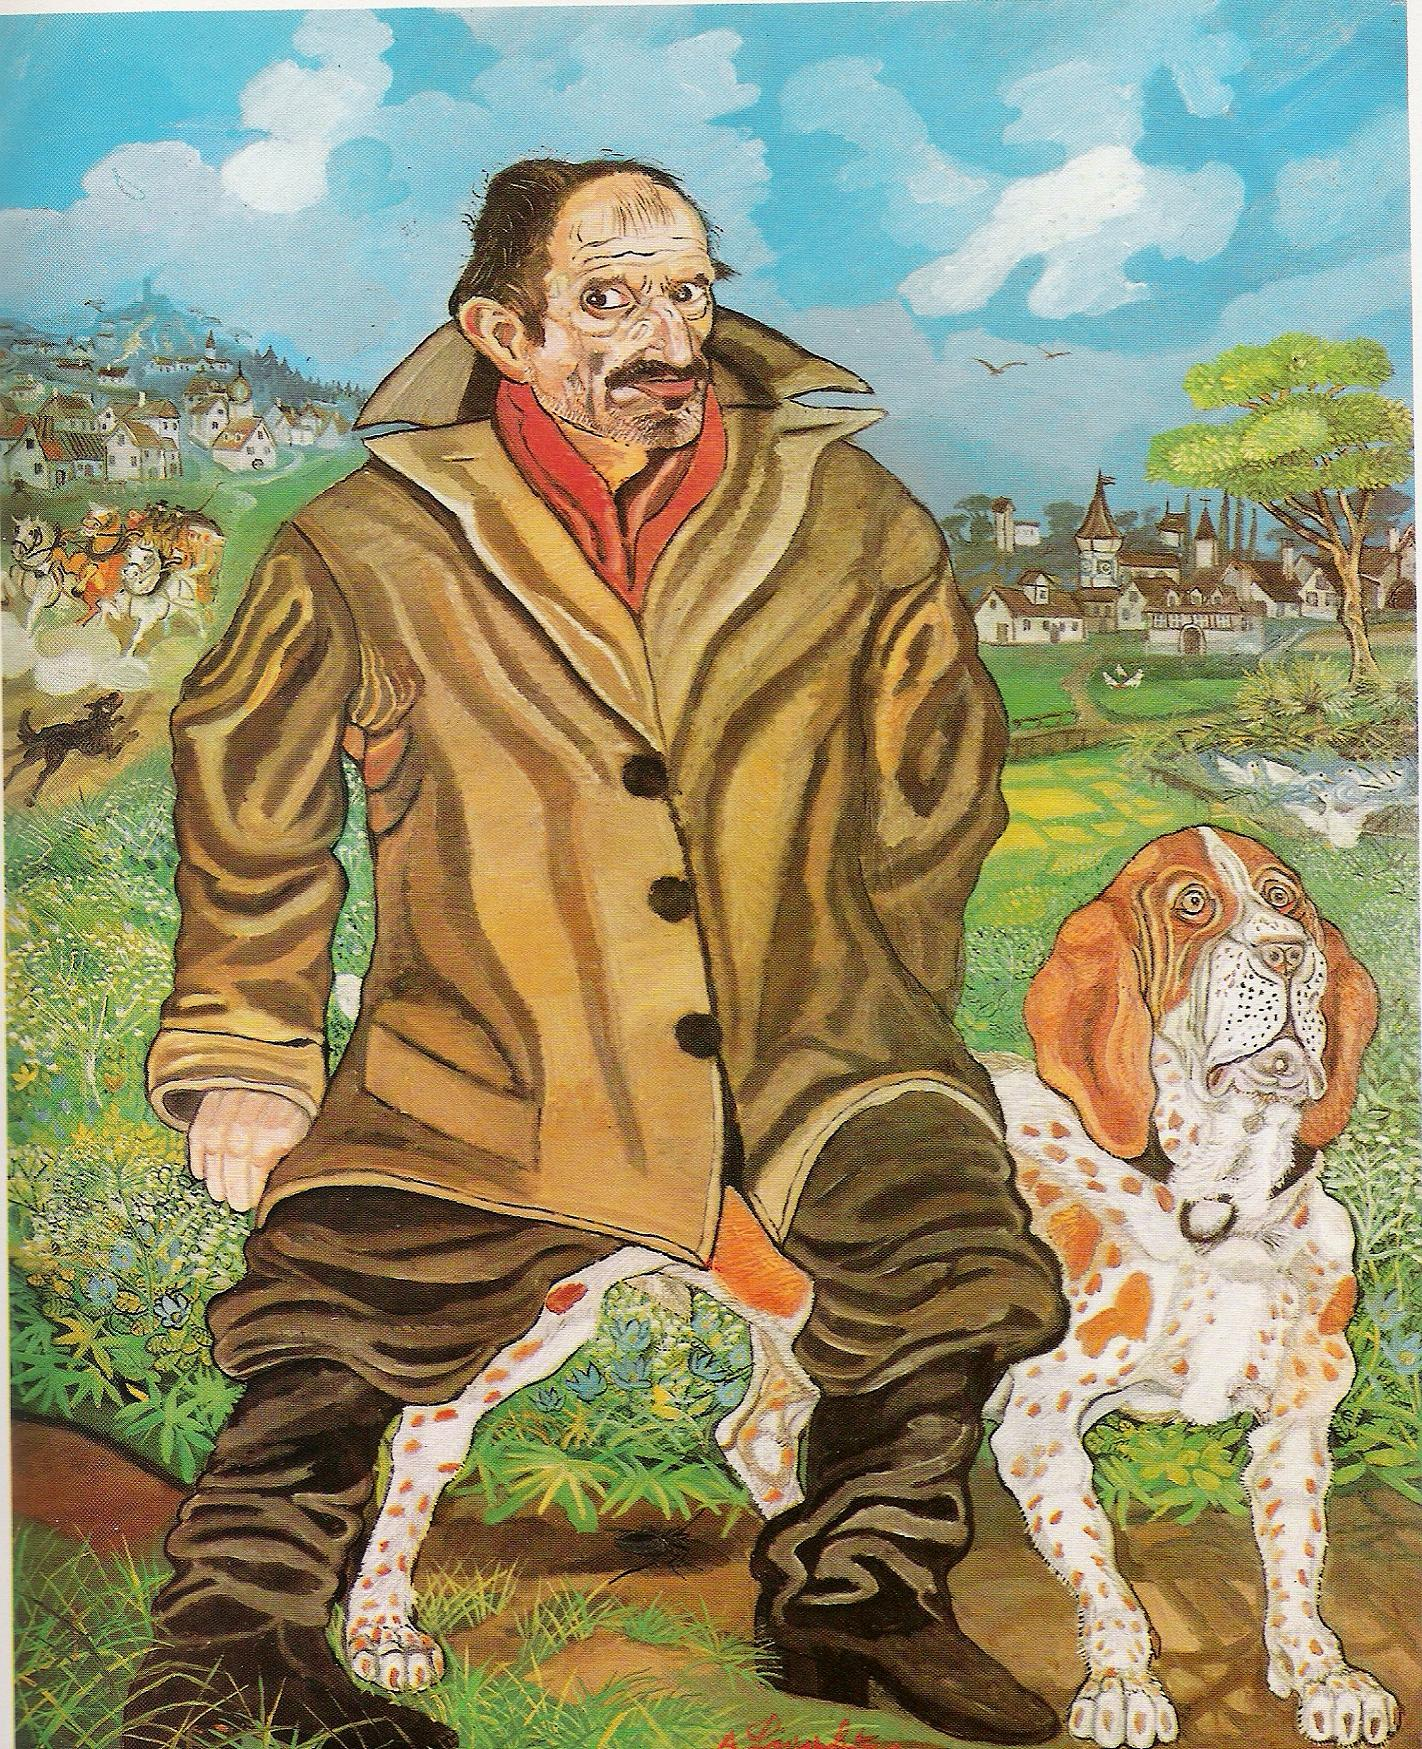Could you tell me more about the village in the background? The village in the background is depicted with a remarkable sense of charm and detail. Nestled among rolling green hills, the village features quaint houses with steep roofs, arranged in a seemingly peaceful manner. In the center, there’s a prominent clock tower that likely serves as an essential meeting point for the villagers. Beyond the village, there is a castle perched on a distant hill, suggesting a place of significance or perhaps a seat of local governance. The vibrant colors and the whimsical style give the village a magical feel, almost as if it could be a setting for a fairy tale story. Could this village have a special historical or magical significance? Absolutely, the village depicted here seems to encompass a deep sense of historical and possibly magical significance. The meticulous details of the buildings and the majestic castle suggest a storied past, perhaps of valiant knights, noble deeds, and royal heritage. The artistic style further evokes a sense of enchantment, where the village might be home to mystical beings, ancient secrets, or wise folklore that has been passed down through generations. Its depiction in such vibrant hues and dreamlike setting hints at a place where history intertwines with fantasy, making it a perfect backdrop for imaginative tales and adventures. 